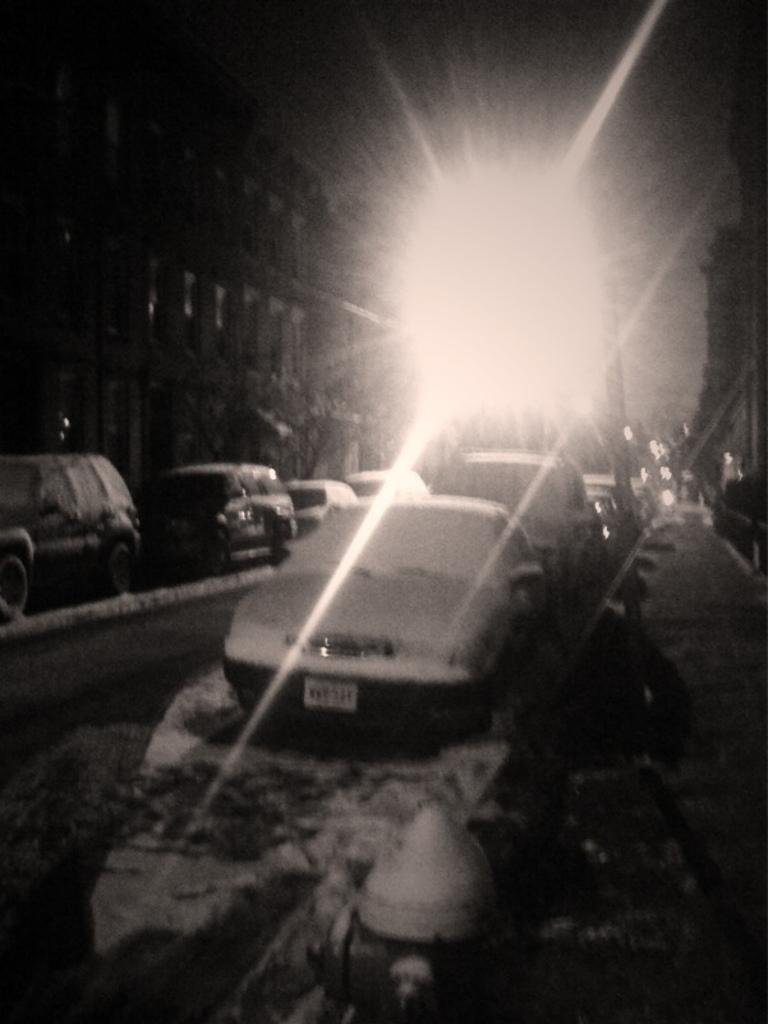How would you summarize this image in a sentence or two? In this picture we can see the road with some cars parked on the roadside covered with snow. Behind we can see the building. On the top there is a light. 